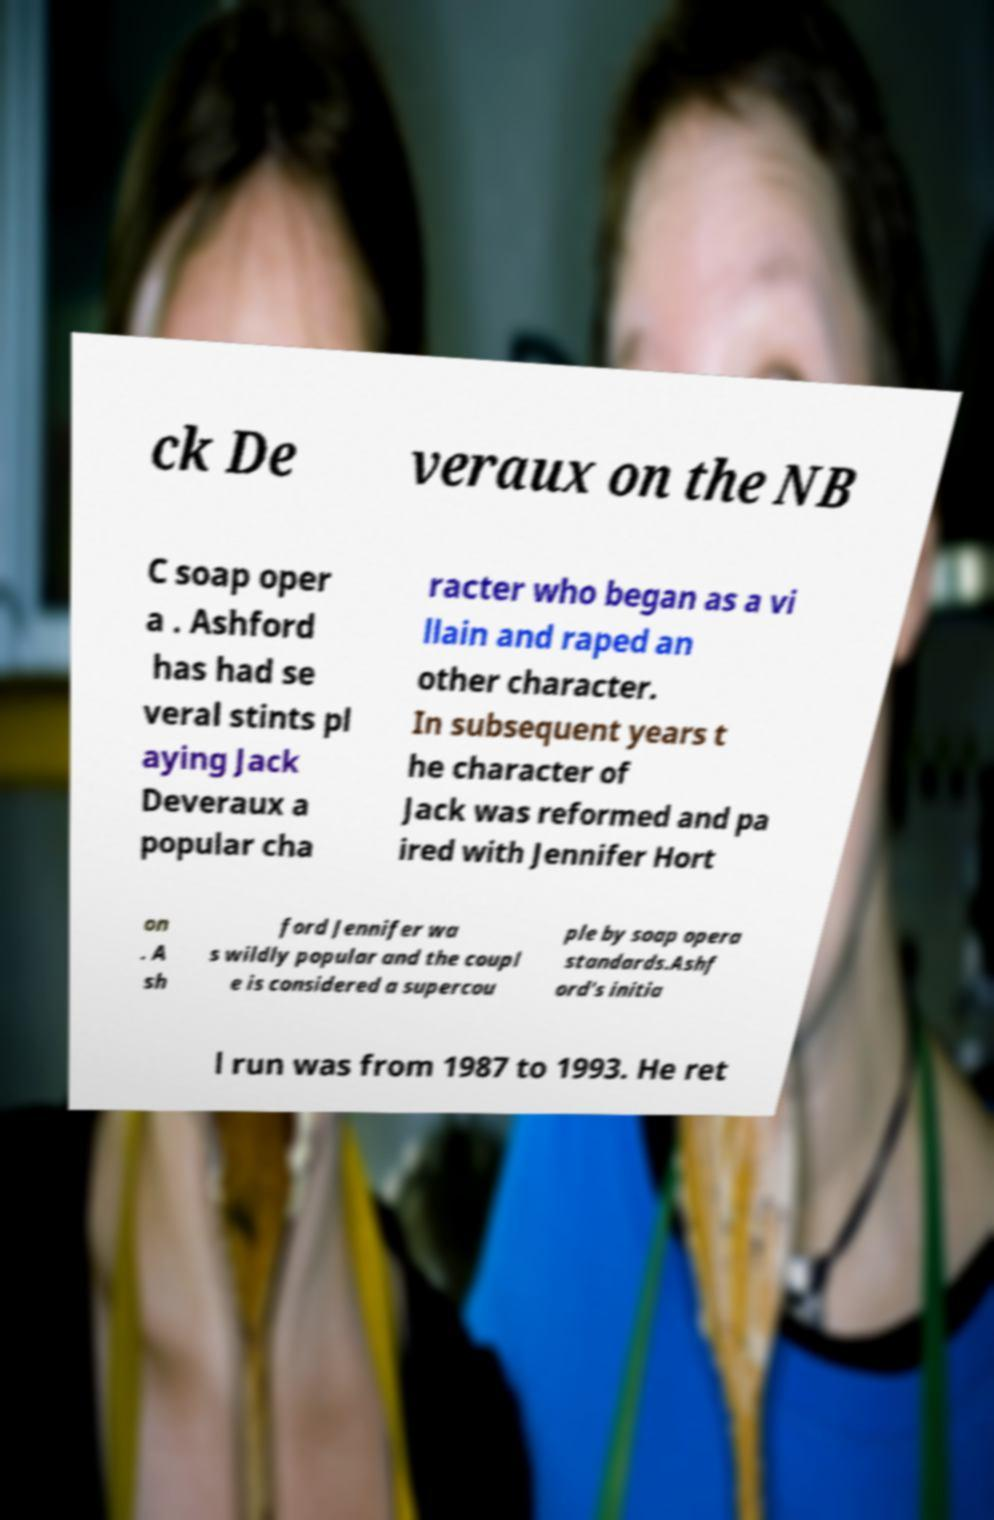Can you read and provide the text displayed in the image?This photo seems to have some interesting text. Can you extract and type it out for me? ck De veraux on the NB C soap oper a . Ashford has had se veral stints pl aying Jack Deveraux a popular cha racter who began as a vi llain and raped an other character. In subsequent years t he character of Jack was reformed and pa ired with Jennifer Hort on . A sh ford Jennifer wa s wildly popular and the coupl e is considered a supercou ple by soap opera standards.Ashf ord's initia l run was from 1987 to 1993. He ret 